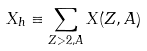Convert formula to latex. <formula><loc_0><loc_0><loc_500><loc_500>X _ { h } \equiv \sum _ { Z > 2 , A } X ( Z , A )</formula> 